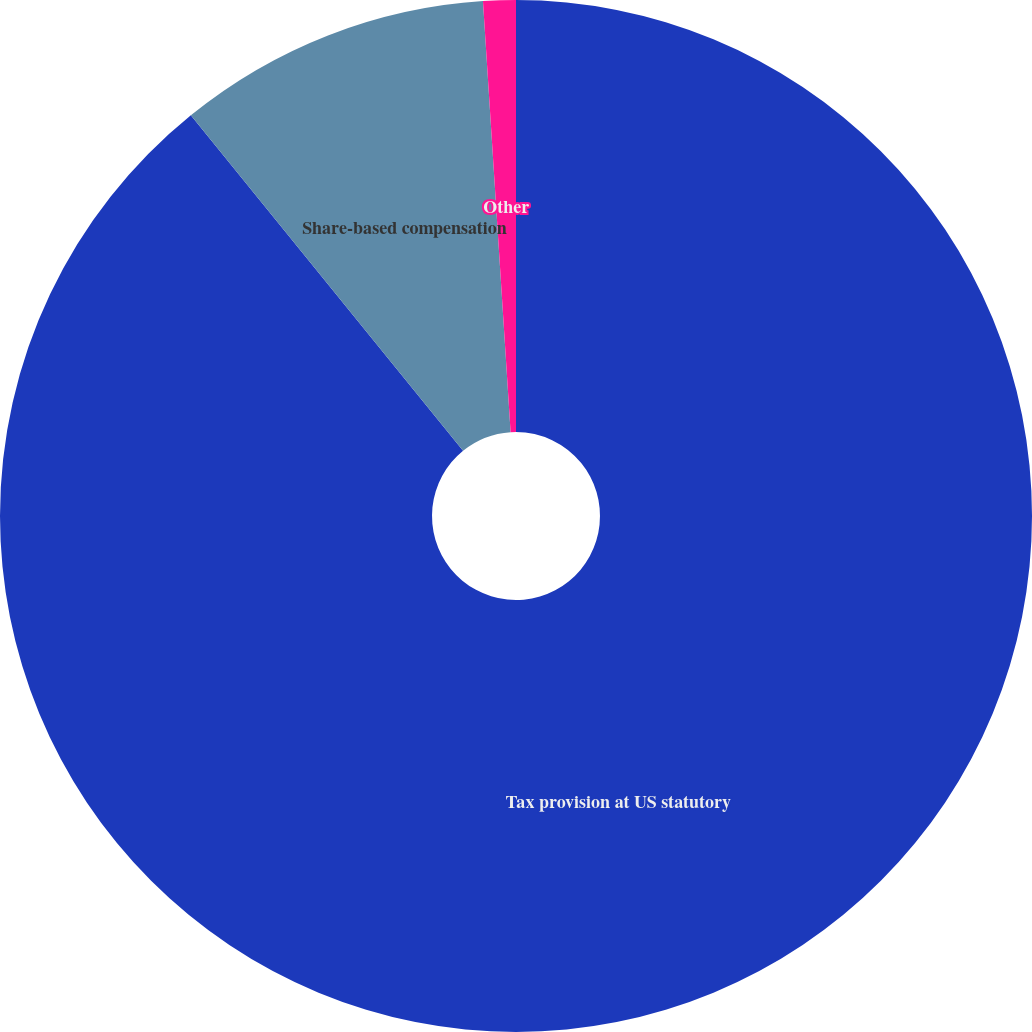<chart> <loc_0><loc_0><loc_500><loc_500><pie_chart><fcel>Tax provision at US statutory<fcel>Share-based compensation<fcel>Other<nl><fcel>89.15%<fcel>9.83%<fcel>1.02%<nl></chart> 